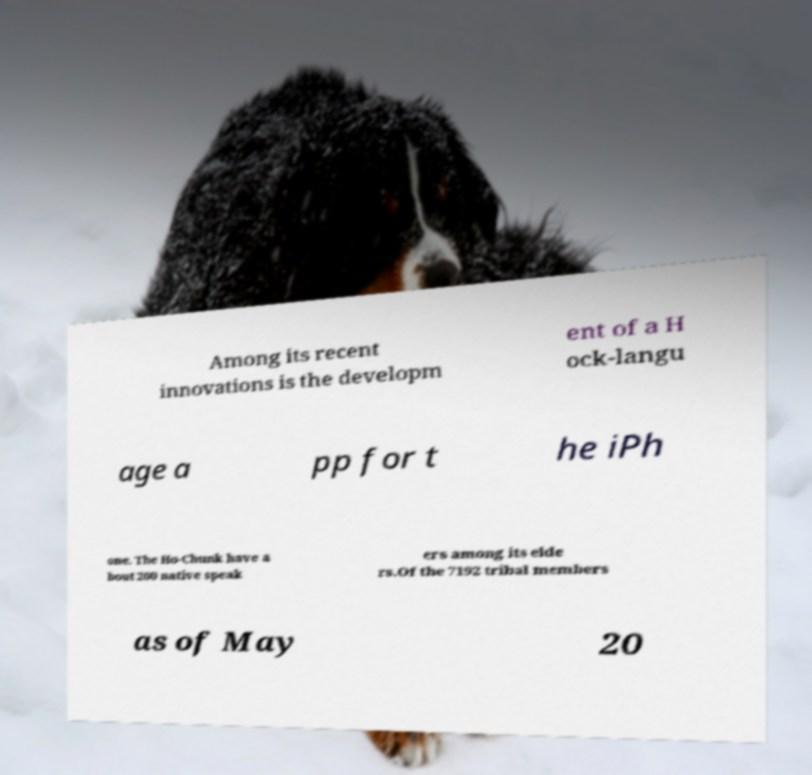What messages or text are displayed in this image? I need them in a readable, typed format. Among its recent innovations is the developm ent of a H ock-langu age a pp for t he iPh one. The Ho-Chunk have a bout 200 native speak ers among its elde rs.Of the 7192 tribal members as of May 20 